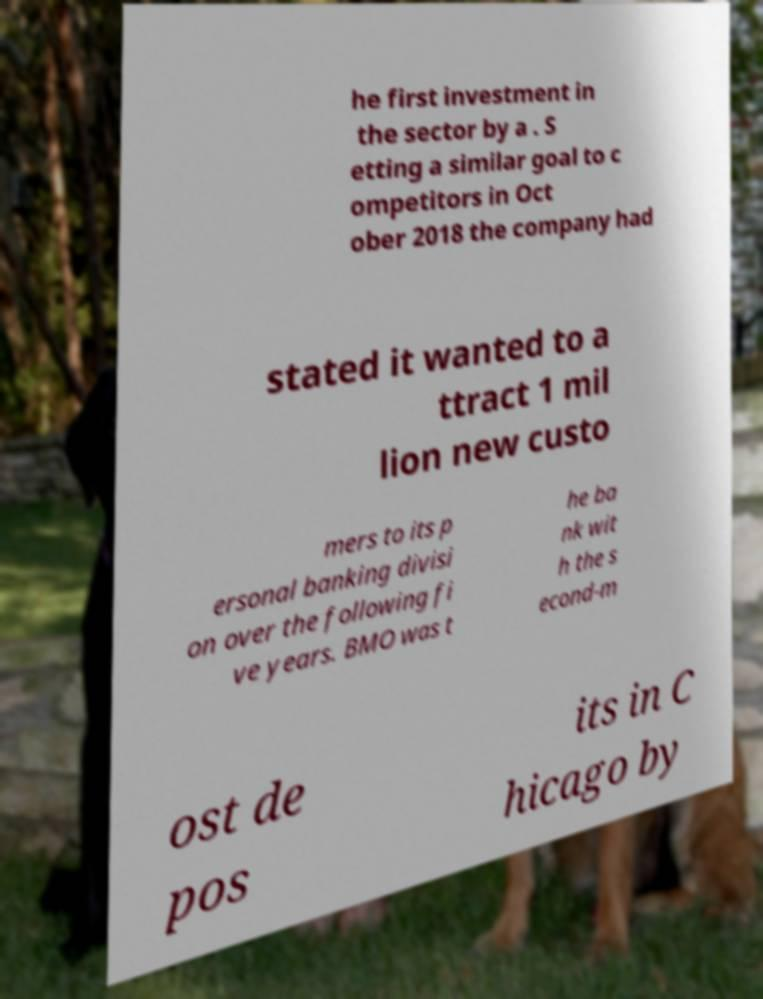Can you read and provide the text displayed in the image?This photo seems to have some interesting text. Can you extract and type it out for me? he first investment in the sector by a . S etting a similar goal to c ompetitors in Oct ober 2018 the company had stated it wanted to a ttract 1 mil lion new custo mers to its p ersonal banking divisi on over the following fi ve years. BMO was t he ba nk wit h the s econd-m ost de pos its in C hicago by 